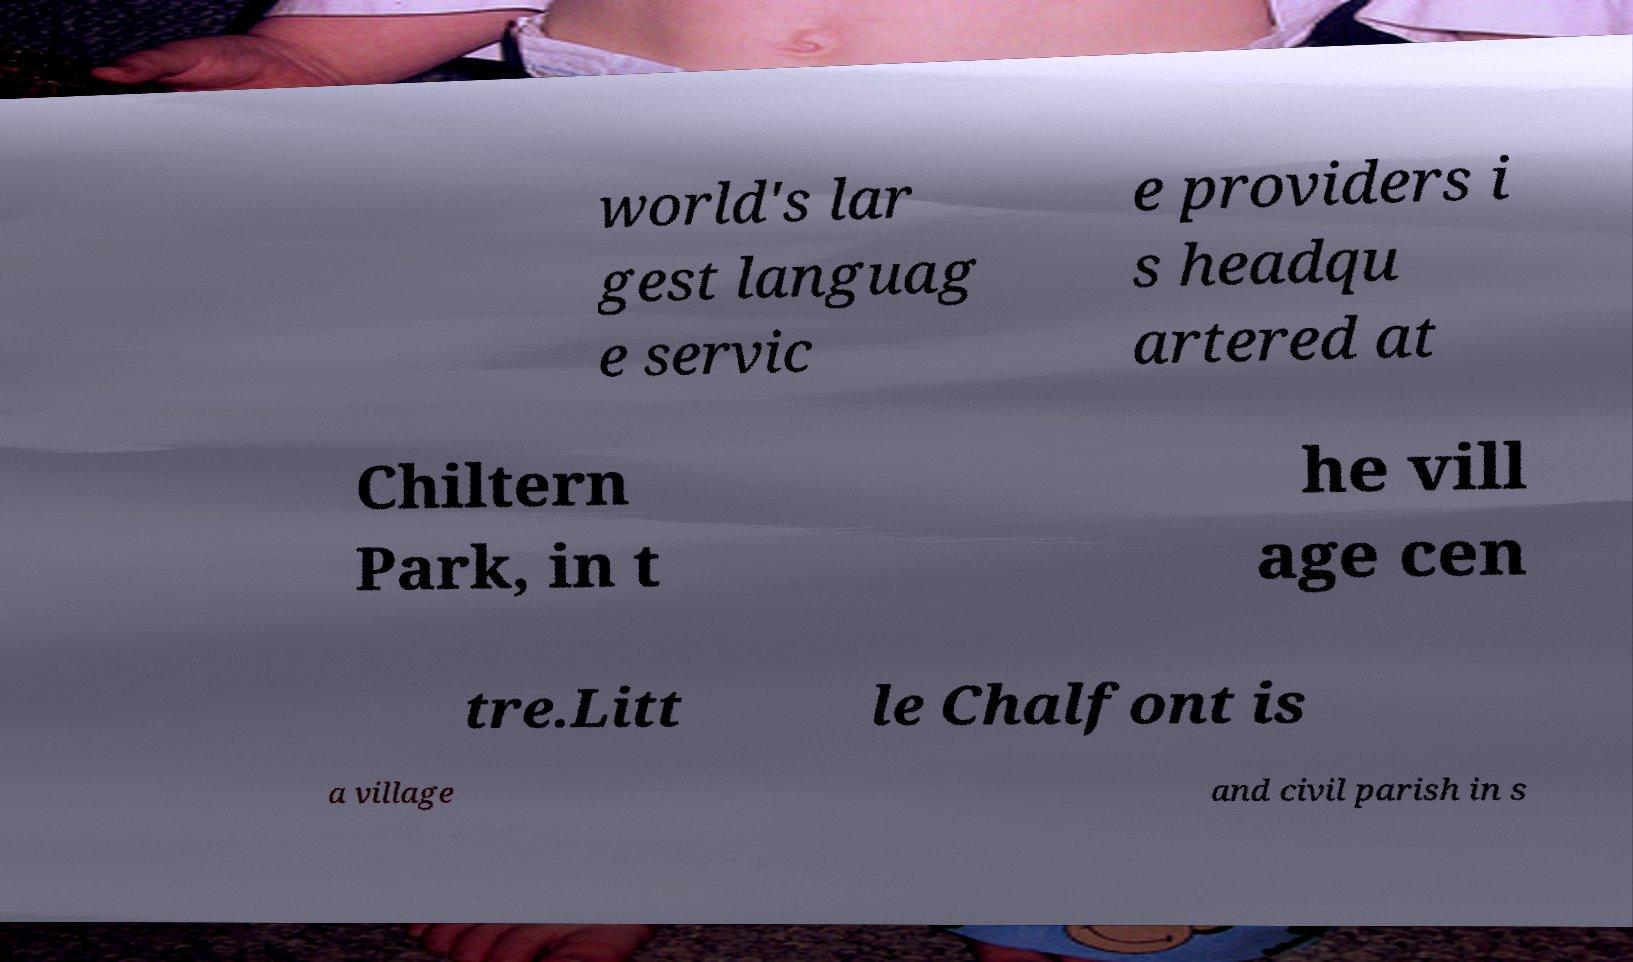I need the written content from this picture converted into text. Can you do that? world's lar gest languag e servic e providers i s headqu artered at Chiltern Park, in t he vill age cen tre.Litt le Chalfont is a village and civil parish in s 